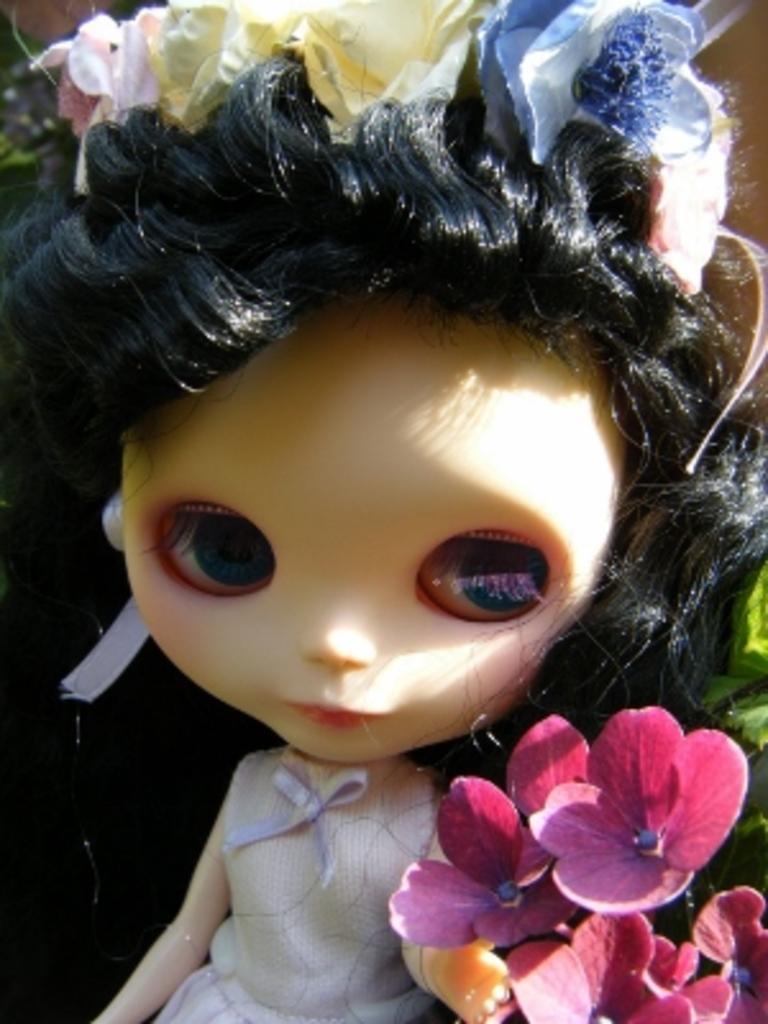Describe this image in one or two sentences. In this image in the center there is one doll, and on the right side there are some flowers. 